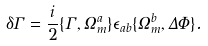Convert formula to latex. <formula><loc_0><loc_0><loc_500><loc_500>\delta \Gamma = \frac { i } { 2 } \{ \Gamma , \Omega _ { m } ^ { a } \} \epsilon _ { a b } \{ \Omega _ { m } ^ { b } , \Delta \Phi \} .</formula> 